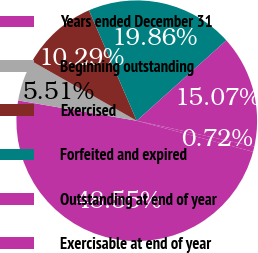<chart> <loc_0><loc_0><loc_500><loc_500><pie_chart><fcel>Years ended December 31<fcel>Beginning outstanding<fcel>Exercised<fcel>Forfeited and expired<fcel>Outstanding at end of year<fcel>Exercisable at end of year<nl><fcel>48.55%<fcel>5.51%<fcel>10.29%<fcel>19.86%<fcel>15.07%<fcel>0.72%<nl></chart> 